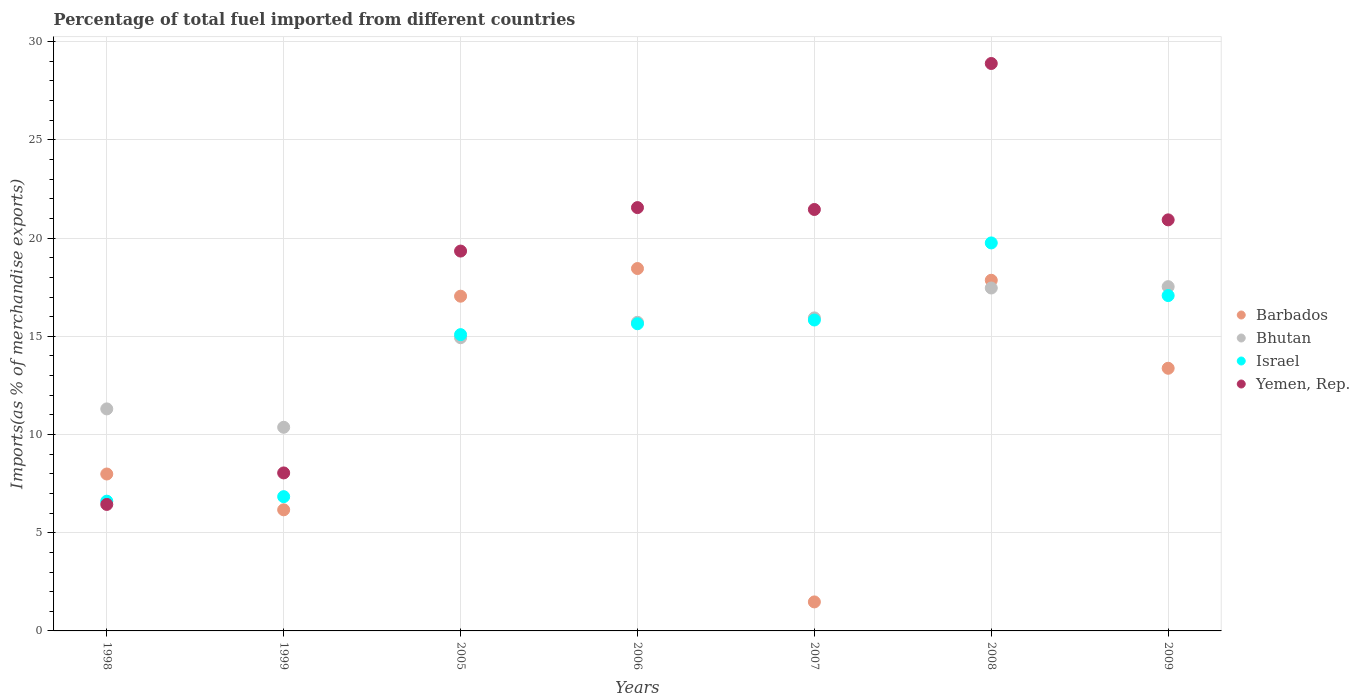How many different coloured dotlines are there?
Keep it short and to the point. 4. What is the percentage of imports to different countries in Barbados in 2009?
Offer a very short reply. 13.37. Across all years, what is the maximum percentage of imports to different countries in Bhutan?
Give a very brief answer. 17.53. Across all years, what is the minimum percentage of imports to different countries in Yemen, Rep.?
Ensure brevity in your answer.  6.44. In which year was the percentage of imports to different countries in Yemen, Rep. maximum?
Your response must be concise. 2008. In which year was the percentage of imports to different countries in Bhutan minimum?
Your response must be concise. 1999. What is the total percentage of imports to different countries in Israel in the graph?
Your answer should be compact. 96.83. What is the difference between the percentage of imports to different countries in Israel in 1999 and that in 2008?
Provide a succinct answer. -12.92. What is the difference between the percentage of imports to different countries in Barbados in 2006 and the percentage of imports to different countries in Yemen, Rep. in 1998?
Offer a terse response. 12.01. What is the average percentage of imports to different countries in Israel per year?
Provide a short and direct response. 13.83. In the year 1998, what is the difference between the percentage of imports to different countries in Barbados and percentage of imports to different countries in Bhutan?
Provide a succinct answer. -3.31. What is the ratio of the percentage of imports to different countries in Israel in 1999 to that in 2006?
Give a very brief answer. 0.44. Is the percentage of imports to different countries in Bhutan in 2005 less than that in 2006?
Your answer should be compact. Yes. What is the difference between the highest and the second highest percentage of imports to different countries in Israel?
Provide a succinct answer. 2.68. What is the difference between the highest and the lowest percentage of imports to different countries in Israel?
Offer a very short reply. 13.15. In how many years, is the percentage of imports to different countries in Yemen, Rep. greater than the average percentage of imports to different countries in Yemen, Rep. taken over all years?
Give a very brief answer. 5. Is it the case that in every year, the sum of the percentage of imports to different countries in Barbados and percentage of imports to different countries in Israel  is greater than the sum of percentage of imports to different countries in Yemen, Rep. and percentage of imports to different countries in Bhutan?
Keep it short and to the point. No. Is it the case that in every year, the sum of the percentage of imports to different countries in Barbados and percentage of imports to different countries in Yemen, Rep.  is greater than the percentage of imports to different countries in Israel?
Give a very brief answer. Yes. Is the percentage of imports to different countries in Barbados strictly less than the percentage of imports to different countries in Yemen, Rep. over the years?
Your response must be concise. No. What is the difference between two consecutive major ticks on the Y-axis?
Give a very brief answer. 5. Does the graph contain any zero values?
Your response must be concise. No. Does the graph contain grids?
Your answer should be very brief. Yes. How many legend labels are there?
Ensure brevity in your answer.  4. How are the legend labels stacked?
Ensure brevity in your answer.  Vertical. What is the title of the graph?
Offer a terse response. Percentage of total fuel imported from different countries. Does "Japan" appear as one of the legend labels in the graph?
Offer a terse response. No. What is the label or title of the X-axis?
Provide a succinct answer. Years. What is the label or title of the Y-axis?
Ensure brevity in your answer.  Imports(as % of merchandise exports). What is the Imports(as % of merchandise exports) in Barbados in 1998?
Keep it short and to the point. 7.99. What is the Imports(as % of merchandise exports) of Bhutan in 1998?
Offer a very short reply. 11.3. What is the Imports(as % of merchandise exports) in Israel in 1998?
Your answer should be very brief. 6.61. What is the Imports(as % of merchandise exports) of Yemen, Rep. in 1998?
Ensure brevity in your answer.  6.44. What is the Imports(as % of merchandise exports) in Barbados in 1999?
Keep it short and to the point. 6.17. What is the Imports(as % of merchandise exports) of Bhutan in 1999?
Make the answer very short. 10.37. What is the Imports(as % of merchandise exports) in Israel in 1999?
Make the answer very short. 6.84. What is the Imports(as % of merchandise exports) of Yemen, Rep. in 1999?
Make the answer very short. 8.04. What is the Imports(as % of merchandise exports) in Barbados in 2005?
Make the answer very short. 17.04. What is the Imports(as % of merchandise exports) of Bhutan in 2005?
Provide a succinct answer. 14.93. What is the Imports(as % of merchandise exports) of Israel in 2005?
Offer a very short reply. 15.09. What is the Imports(as % of merchandise exports) of Yemen, Rep. in 2005?
Make the answer very short. 19.34. What is the Imports(as % of merchandise exports) of Barbados in 2006?
Provide a succinct answer. 18.45. What is the Imports(as % of merchandise exports) of Bhutan in 2006?
Your answer should be compact. 15.71. What is the Imports(as % of merchandise exports) in Israel in 2006?
Your answer should be compact. 15.64. What is the Imports(as % of merchandise exports) of Yemen, Rep. in 2006?
Keep it short and to the point. 21.55. What is the Imports(as % of merchandise exports) in Barbados in 2007?
Ensure brevity in your answer.  1.48. What is the Imports(as % of merchandise exports) of Bhutan in 2007?
Your response must be concise. 15.94. What is the Imports(as % of merchandise exports) of Israel in 2007?
Provide a succinct answer. 15.83. What is the Imports(as % of merchandise exports) in Yemen, Rep. in 2007?
Keep it short and to the point. 21.46. What is the Imports(as % of merchandise exports) in Barbados in 2008?
Offer a terse response. 17.85. What is the Imports(as % of merchandise exports) in Bhutan in 2008?
Your answer should be compact. 17.46. What is the Imports(as % of merchandise exports) of Israel in 2008?
Give a very brief answer. 19.76. What is the Imports(as % of merchandise exports) in Yemen, Rep. in 2008?
Provide a succinct answer. 28.89. What is the Imports(as % of merchandise exports) in Barbados in 2009?
Make the answer very short. 13.37. What is the Imports(as % of merchandise exports) in Bhutan in 2009?
Keep it short and to the point. 17.53. What is the Imports(as % of merchandise exports) of Israel in 2009?
Provide a short and direct response. 17.07. What is the Imports(as % of merchandise exports) of Yemen, Rep. in 2009?
Provide a short and direct response. 20.93. Across all years, what is the maximum Imports(as % of merchandise exports) in Barbados?
Make the answer very short. 18.45. Across all years, what is the maximum Imports(as % of merchandise exports) of Bhutan?
Your answer should be very brief. 17.53. Across all years, what is the maximum Imports(as % of merchandise exports) of Israel?
Offer a terse response. 19.76. Across all years, what is the maximum Imports(as % of merchandise exports) in Yemen, Rep.?
Provide a succinct answer. 28.89. Across all years, what is the minimum Imports(as % of merchandise exports) in Barbados?
Offer a terse response. 1.48. Across all years, what is the minimum Imports(as % of merchandise exports) in Bhutan?
Provide a short and direct response. 10.37. Across all years, what is the minimum Imports(as % of merchandise exports) in Israel?
Your answer should be compact. 6.61. Across all years, what is the minimum Imports(as % of merchandise exports) in Yemen, Rep.?
Your response must be concise. 6.44. What is the total Imports(as % of merchandise exports) in Barbados in the graph?
Ensure brevity in your answer.  82.36. What is the total Imports(as % of merchandise exports) in Bhutan in the graph?
Provide a short and direct response. 103.24. What is the total Imports(as % of merchandise exports) of Israel in the graph?
Offer a terse response. 96.83. What is the total Imports(as % of merchandise exports) in Yemen, Rep. in the graph?
Ensure brevity in your answer.  126.66. What is the difference between the Imports(as % of merchandise exports) of Barbados in 1998 and that in 1999?
Your answer should be very brief. 1.82. What is the difference between the Imports(as % of merchandise exports) of Bhutan in 1998 and that in 1999?
Give a very brief answer. 0.94. What is the difference between the Imports(as % of merchandise exports) of Israel in 1998 and that in 1999?
Give a very brief answer. -0.23. What is the difference between the Imports(as % of merchandise exports) of Yemen, Rep. in 1998 and that in 1999?
Provide a succinct answer. -1.6. What is the difference between the Imports(as % of merchandise exports) of Barbados in 1998 and that in 2005?
Make the answer very short. -9.05. What is the difference between the Imports(as % of merchandise exports) of Bhutan in 1998 and that in 2005?
Your answer should be very brief. -3.62. What is the difference between the Imports(as % of merchandise exports) in Israel in 1998 and that in 2005?
Keep it short and to the point. -8.48. What is the difference between the Imports(as % of merchandise exports) in Yemen, Rep. in 1998 and that in 2005?
Give a very brief answer. -12.9. What is the difference between the Imports(as % of merchandise exports) of Barbados in 1998 and that in 2006?
Provide a short and direct response. -10.46. What is the difference between the Imports(as % of merchandise exports) of Bhutan in 1998 and that in 2006?
Provide a short and direct response. -4.41. What is the difference between the Imports(as % of merchandise exports) in Israel in 1998 and that in 2006?
Offer a terse response. -9.03. What is the difference between the Imports(as % of merchandise exports) in Yemen, Rep. in 1998 and that in 2006?
Keep it short and to the point. -15.11. What is the difference between the Imports(as % of merchandise exports) of Barbados in 1998 and that in 2007?
Your answer should be very brief. 6.51. What is the difference between the Imports(as % of merchandise exports) of Bhutan in 1998 and that in 2007?
Offer a very short reply. -4.63. What is the difference between the Imports(as % of merchandise exports) of Israel in 1998 and that in 2007?
Your answer should be very brief. -9.22. What is the difference between the Imports(as % of merchandise exports) in Yemen, Rep. in 1998 and that in 2007?
Give a very brief answer. -15.02. What is the difference between the Imports(as % of merchandise exports) in Barbados in 1998 and that in 2008?
Your answer should be compact. -9.86. What is the difference between the Imports(as % of merchandise exports) in Bhutan in 1998 and that in 2008?
Make the answer very short. -6.16. What is the difference between the Imports(as % of merchandise exports) of Israel in 1998 and that in 2008?
Keep it short and to the point. -13.15. What is the difference between the Imports(as % of merchandise exports) of Yemen, Rep. in 1998 and that in 2008?
Provide a short and direct response. -22.45. What is the difference between the Imports(as % of merchandise exports) in Barbados in 1998 and that in 2009?
Offer a terse response. -5.38. What is the difference between the Imports(as % of merchandise exports) of Bhutan in 1998 and that in 2009?
Provide a short and direct response. -6.22. What is the difference between the Imports(as % of merchandise exports) of Israel in 1998 and that in 2009?
Keep it short and to the point. -10.47. What is the difference between the Imports(as % of merchandise exports) in Yemen, Rep. in 1998 and that in 2009?
Provide a succinct answer. -14.49. What is the difference between the Imports(as % of merchandise exports) in Barbados in 1999 and that in 2005?
Provide a short and direct response. -10.88. What is the difference between the Imports(as % of merchandise exports) in Bhutan in 1999 and that in 2005?
Offer a terse response. -4.56. What is the difference between the Imports(as % of merchandise exports) in Israel in 1999 and that in 2005?
Make the answer very short. -8.25. What is the difference between the Imports(as % of merchandise exports) of Yemen, Rep. in 1999 and that in 2005?
Keep it short and to the point. -11.3. What is the difference between the Imports(as % of merchandise exports) of Barbados in 1999 and that in 2006?
Make the answer very short. -12.29. What is the difference between the Imports(as % of merchandise exports) in Bhutan in 1999 and that in 2006?
Your answer should be compact. -5.35. What is the difference between the Imports(as % of merchandise exports) of Israel in 1999 and that in 2006?
Your answer should be compact. -8.8. What is the difference between the Imports(as % of merchandise exports) in Yemen, Rep. in 1999 and that in 2006?
Make the answer very short. -13.51. What is the difference between the Imports(as % of merchandise exports) of Barbados in 1999 and that in 2007?
Keep it short and to the point. 4.69. What is the difference between the Imports(as % of merchandise exports) in Bhutan in 1999 and that in 2007?
Offer a terse response. -5.57. What is the difference between the Imports(as % of merchandise exports) of Israel in 1999 and that in 2007?
Provide a short and direct response. -8.99. What is the difference between the Imports(as % of merchandise exports) in Yemen, Rep. in 1999 and that in 2007?
Give a very brief answer. -13.41. What is the difference between the Imports(as % of merchandise exports) of Barbados in 1999 and that in 2008?
Your answer should be compact. -11.69. What is the difference between the Imports(as % of merchandise exports) in Bhutan in 1999 and that in 2008?
Provide a short and direct response. -7.09. What is the difference between the Imports(as % of merchandise exports) of Israel in 1999 and that in 2008?
Offer a very short reply. -12.92. What is the difference between the Imports(as % of merchandise exports) in Yemen, Rep. in 1999 and that in 2008?
Keep it short and to the point. -20.85. What is the difference between the Imports(as % of merchandise exports) in Barbados in 1999 and that in 2009?
Provide a short and direct response. -7.21. What is the difference between the Imports(as % of merchandise exports) of Bhutan in 1999 and that in 2009?
Offer a very short reply. -7.16. What is the difference between the Imports(as % of merchandise exports) of Israel in 1999 and that in 2009?
Ensure brevity in your answer.  -10.24. What is the difference between the Imports(as % of merchandise exports) in Yemen, Rep. in 1999 and that in 2009?
Keep it short and to the point. -12.88. What is the difference between the Imports(as % of merchandise exports) in Barbados in 2005 and that in 2006?
Provide a short and direct response. -1.41. What is the difference between the Imports(as % of merchandise exports) of Bhutan in 2005 and that in 2006?
Your response must be concise. -0.79. What is the difference between the Imports(as % of merchandise exports) in Israel in 2005 and that in 2006?
Keep it short and to the point. -0.55. What is the difference between the Imports(as % of merchandise exports) of Yemen, Rep. in 2005 and that in 2006?
Provide a short and direct response. -2.21. What is the difference between the Imports(as % of merchandise exports) of Barbados in 2005 and that in 2007?
Provide a short and direct response. 15.57. What is the difference between the Imports(as % of merchandise exports) of Bhutan in 2005 and that in 2007?
Ensure brevity in your answer.  -1.01. What is the difference between the Imports(as % of merchandise exports) of Israel in 2005 and that in 2007?
Your answer should be very brief. -0.74. What is the difference between the Imports(as % of merchandise exports) in Yemen, Rep. in 2005 and that in 2007?
Give a very brief answer. -2.12. What is the difference between the Imports(as % of merchandise exports) of Barbados in 2005 and that in 2008?
Give a very brief answer. -0.81. What is the difference between the Imports(as % of merchandise exports) of Bhutan in 2005 and that in 2008?
Offer a terse response. -2.53. What is the difference between the Imports(as % of merchandise exports) in Israel in 2005 and that in 2008?
Offer a very short reply. -4.67. What is the difference between the Imports(as % of merchandise exports) in Yemen, Rep. in 2005 and that in 2008?
Give a very brief answer. -9.55. What is the difference between the Imports(as % of merchandise exports) of Barbados in 2005 and that in 2009?
Ensure brevity in your answer.  3.67. What is the difference between the Imports(as % of merchandise exports) in Bhutan in 2005 and that in 2009?
Make the answer very short. -2.6. What is the difference between the Imports(as % of merchandise exports) of Israel in 2005 and that in 2009?
Provide a succinct answer. -1.99. What is the difference between the Imports(as % of merchandise exports) of Yemen, Rep. in 2005 and that in 2009?
Keep it short and to the point. -1.59. What is the difference between the Imports(as % of merchandise exports) in Barbados in 2006 and that in 2007?
Your response must be concise. 16.97. What is the difference between the Imports(as % of merchandise exports) in Bhutan in 2006 and that in 2007?
Provide a short and direct response. -0.22. What is the difference between the Imports(as % of merchandise exports) in Israel in 2006 and that in 2007?
Provide a succinct answer. -0.19. What is the difference between the Imports(as % of merchandise exports) of Yemen, Rep. in 2006 and that in 2007?
Provide a short and direct response. 0.1. What is the difference between the Imports(as % of merchandise exports) in Barbados in 2006 and that in 2008?
Provide a succinct answer. 0.6. What is the difference between the Imports(as % of merchandise exports) of Bhutan in 2006 and that in 2008?
Your answer should be very brief. -1.75. What is the difference between the Imports(as % of merchandise exports) in Israel in 2006 and that in 2008?
Your answer should be very brief. -4.11. What is the difference between the Imports(as % of merchandise exports) in Yemen, Rep. in 2006 and that in 2008?
Your response must be concise. -7.34. What is the difference between the Imports(as % of merchandise exports) in Barbados in 2006 and that in 2009?
Provide a short and direct response. 5.08. What is the difference between the Imports(as % of merchandise exports) of Bhutan in 2006 and that in 2009?
Give a very brief answer. -1.81. What is the difference between the Imports(as % of merchandise exports) of Israel in 2006 and that in 2009?
Provide a short and direct response. -1.43. What is the difference between the Imports(as % of merchandise exports) in Yemen, Rep. in 2006 and that in 2009?
Keep it short and to the point. 0.62. What is the difference between the Imports(as % of merchandise exports) in Barbados in 2007 and that in 2008?
Your answer should be compact. -16.38. What is the difference between the Imports(as % of merchandise exports) of Bhutan in 2007 and that in 2008?
Make the answer very short. -1.52. What is the difference between the Imports(as % of merchandise exports) of Israel in 2007 and that in 2008?
Offer a very short reply. -3.92. What is the difference between the Imports(as % of merchandise exports) of Yemen, Rep. in 2007 and that in 2008?
Your answer should be very brief. -7.43. What is the difference between the Imports(as % of merchandise exports) in Barbados in 2007 and that in 2009?
Ensure brevity in your answer.  -11.9. What is the difference between the Imports(as % of merchandise exports) in Bhutan in 2007 and that in 2009?
Make the answer very short. -1.59. What is the difference between the Imports(as % of merchandise exports) in Israel in 2007 and that in 2009?
Offer a terse response. -1.24. What is the difference between the Imports(as % of merchandise exports) of Yemen, Rep. in 2007 and that in 2009?
Provide a short and direct response. 0.53. What is the difference between the Imports(as % of merchandise exports) of Barbados in 2008 and that in 2009?
Offer a very short reply. 4.48. What is the difference between the Imports(as % of merchandise exports) in Bhutan in 2008 and that in 2009?
Make the answer very short. -0.07. What is the difference between the Imports(as % of merchandise exports) in Israel in 2008 and that in 2009?
Provide a short and direct response. 2.68. What is the difference between the Imports(as % of merchandise exports) of Yemen, Rep. in 2008 and that in 2009?
Offer a very short reply. 7.96. What is the difference between the Imports(as % of merchandise exports) in Barbados in 1998 and the Imports(as % of merchandise exports) in Bhutan in 1999?
Make the answer very short. -2.38. What is the difference between the Imports(as % of merchandise exports) in Barbados in 1998 and the Imports(as % of merchandise exports) in Israel in 1999?
Keep it short and to the point. 1.15. What is the difference between the Imports(as % of merchandise exports) in Barbados in 1998 and the Imports(as % of merchandise exports) in Yemen, Rep. in 1999?
Provide a short and direct response. -0.05. What is the difference between the Imports(as % of merchandise exports) in Bhutan in 1998 and the Imports(as % of merchandise exports) in Israel in 1999?
Keep it short and to the point. 4.47. What is the difference between the Imports(as % of merchandise exports) of Bhutan in 1998 and the Imports(as % of merchandise exports) of Yemen, Rep. in 1999?
Keep it short and to the point. 3.26. What is the difference between the Imports(as % of merchandise exports) of Israel in 1998 and the Imports(as % of merchandise exports) of Yemen, Rep. in 1999?
Provide a short and direct response. -1.44. What is the difference between the Imports(as % of merchandise exports) in Barbados in 1998 and the Imports(as % of merchandise exports) in Bhutan in 2005?
Provide a succinct answer. -6.94. What is the difference between the Imports(as % of merchandise exports) in Barbados in 1998 and the Imports(as % of merchandise exports) in Israel in 2005?
Ensure brevity in your answer.  -7.1. What is the difference between the Imports(as % of merchandise exports) of Barbados in 1998 and the Imports(as % of merchandise exports) of Yemen, Rep. in 2005?
Ensure brevity in your answer.  -11.35. What is the difference between the Imports(as % of merchandise exports) of Bhutan in 1998 and the Imports(as % of merchandise exports) of Israel in 2005?
Your answer should be compact. -3.78. What is the difference between the Imports(as % of merchandise exports) in Bhutan in 1998 and the Imports(as % of merchandise exports) in Yemen, Rep. in 2005?
Make the answer very short. -8.04. What is the difference between the Imports(as % of merchandise exports) in Israel in 1998 and the Imports(as % of merchandise exports) in Yemen, Rep. in 2005?
Offer a terse response. -12.73. What is the difference between the Imports(as % of merchandise exports) in Barbados in 1998 and the Imports(as % of merchandise exports) in Bhutan in 2006?
Your answer should be compact. -7.72. What is the difference between the Imports(as % of merchandise exports) in Barbados in 1998 and the Imports(as % of merchandise exports) in Israel in 2006?
Your answer should be very brief. -7.65. What is the difference between the Imports(as % of merchandise exports) in Barbados in 1998 and the Imports(as % of merchandise exports) in Yemen, Rep. in 2006?
Ensure brevity in your answer.  -13.56. What is the difference between the Imports(as % of merchandise exports) of Bhutan in 1998 and the Imports(as % of merchandise exports) of Israel in 2006?
Give a very brief answer. -4.34. What is the difference between the Imports(as % of merchandise exports) of Bhutan in 1998 and the Imports(as % of merchandise exports) of Yemen, Rep. in 2006?
Your answer should be very brief. -10.25. What is the difference between the Imports(as % of merchandise exports) in Israel in 1998 and the Imports(as % of merchandise exports) in Yemen, Rep. in 2006?
Give a very brief answer. -14.95. What is the difference between the Imports(as % of merchandise exports) in Barbados in 1998 and the Imports(as % of merchandise exports) in Bhutan in 2007?
Keep it short and to the point. -7.95. What is the difference between the Imports(as % of merchandise exports) of Barbados in 1998 and the Imports(as % of merchandise exports) of Israel in 2007?
Your response must be concise. -7.84. What is the difference between the Imports(as % of merchandise exports) in Barbados in 1998 and the Imports(as % of merchandise exports) in Yemen, Rep. in 2007?
Make the answer very short. -13.47. What is the difference between the Imports(as % of merchandise exports) in Bhutan in 1998 and the Imports(as % of merchandise exports) in Israel in 2007?
Provide a short and direct response. -4.53. What is the difference between the Imports(as % of merchandise exports) of Bhutan in 1998 and the Imports(as % of merchandise exports) of Yemen, Rep. in 2007?
Keep it short and to the point. -10.15. What is the difference between the Imports(as % of merchandise exports) in Israel in 1998 and the Imports(as % of merchandise exports) in Yemen, Rep. in 2007?
Your answer should be compact. -14.85. What is the difference between the Imports(as % of merchandise exports) of Barbados in 1998 and the Imports(as % of merchandise exports) of Bhutan in 2008?
Ensure brevity in your answer.  -9.47. What is the difference between the Imports(as % of merchandise exports) of Barbados in 1998 and the Imports(as % of merchandise exports) of Israel in 2008?
Make the answer very short. -11.77. What is the difference between the Imports(as % of merchandise exports) in Barbados in 1998 and the Imports(as % of merchandise exports) in Yemen, Rep. in 2008?
Give a very brief answer. -20.9. What is the difference between the Imports(as % of merchandise exports) in Bhutan in 1998 and the Imports(as % of merchandise exports) in Israel in 2008?
Provide a succinct answer. -8.45. What is the difference between the Imports(as % of merchandise exports) of Bhutan in 1998 and the Imports(as % of merchandise exports) of Yemen, Rep. in 2008?
Provide a short and direct response. -17.59. What is the difference between the Imports(as % of merchandise exports) of Israel in 1998 and the Imports(as % of merchandise exports) of Yemen, Rep. in 2008?
Your response must be concise. -22.28. What is the difference between the Imports(as % of merchandise exports) in Barbados in 1998 and the Imports(as % of merchandise exports) in Bhutan in 2009?
Your response must be concise. -9.54. What is the difference between the Imports(as % of merchandise exports) of Barbados in 1998 and the Imports(as % of merchandise exports) of Israel in 2009?
Provide a short and direct response. -9.08. What is the difference between the Imports(as % of merchandise exports) in Barbados in 1998 and the Imports(as % of merchandise exports) in Yemen, Rep. in 2009?
Provide a short and direct response. -12.94. What is the difference between the Imports(as % of merchandise exports) in Bhutan in 1998 and the Imports(as % of merchandise exports) in Israel in 2009?
Keep it short and to the point. -5.77. What is the difference between the Imports(as % of merchandise exports) of Bhutan in 1998 and the Imports(as % of merchandise exports) of Yemen, Rep. in 2009?
Make the answer very short. -9.62. What is the difference between the Imports(as % of merchandise exports) in Israel in 1998 and the Imports(as % of merchandise exports) in Yemen, Rep. in 2009?
Your answer should be very brief. -14.32. What is the difference between the Imports(as % of merchandise exports) in Barbados in 1999 and the Imports(as % of merchandise exports) in Bhutan in 2005?
Provide a succinct answer. -8.76. What is the difference between the Imports(as % of merchandise exports) of Barbados in 1999 and the Imports(as % of merchandise exports) of Israel in 2005?
Make the answer very short. -8.92. What is the difference between the Imports(as % of merchandise exports) in Barbados in 1999 and the Imports(as % of merchandise exports) in Yemen, Rep. in 2005?
Offer a very short reply. -13.17. What is the difference between the Imports(as % of merchandise exports) of Bhutan in 1999 and the Imports(as % of merchandise exports) of Israel in 2005?
Offer a terse response. -4.72. What is the difference between the Imports(as % of merchandise exports) of Bhutan in 1999 and the Imports(as % of merchandise exports) of Yemen, Rep. in 2005?
Ensure brevity in your answer.  -8.97. What is the difference between the Imports(as % of merchandise exports) of Israel in 1999 and the Imports(as % of merchandise exports) of Yemen, Rep. in 2005?
Your answer should be very brief. -12.5. What is the difference between the Imports(as % of merchandise exports) of Barbados in 1999 and the Imports(as % of merchandise exports) of Bhutan in 2006?
Give a very brief answer. -9.55. What is the difference between the Imports(as % of merchandise exports) in Barbados in 1999 and the Imports(as % of merchandise exports) in Israel in 2006?
Keep it short and to the point. -9.47. What is the difference between the Imports(as % of merchandise exports) in Barbados in 1999 and the Imports(as % of merchandise exports) in Yemen, Rep. in 2006?
Make the answer very short. -15.39. What is the difference between the Imports(as % of merchandise exports) of Bhutan in 1999 and the Imports(as % of merchandise exports) of Israel in 2006?
Your answer should be compact. -5.27. What is the difference between the Imports(as % of merchandise exports) of Bhutan in 1999 and the Imports(as % of merchandise exports) of Yemen, Rep. in 2006?
Provide a succinct answer. -11.19. What is the difference between the Imports(as % of merchandise exports) of Israel in 1999 and the Imports(as % of merchandise exports) of Yemen, Rep. in 2006?
Give a very brief answer. -14.72. What is the difference between the Imports(as % of merchandise exports) of Barbados in 1999 and the Imports(as % of merchandise exports) of Bhutan in 2007?
Ensure brevity in your answer.  -9.77. What is the difference between the Imports(as % of merchandise exports) of Barbados in 1999 and the Imports(as % of merchandise exports) of Israel in 2007?
Ensure brevity in your answer.  -9.66. What is the difference between the Imports(as % of merchandise exports) in Barbados in 1999 and the Imports(as % of merchandise exports) in Yemen, Rep. in 2007?
Your answer should be compact. -15.29. What is the difference between the Imports(as % of merchandise exports) of Bhutan in 1999 and the Imports(as % of merchandise exports) of Israel in 2007?
Ensure brevity in your answer.  -5.46. What is the difference between the Imports(as % of merchandise exports) of Bhutan in 1999 and the Imports(as % of merchandise exports) of Yemen, Rep. in 2007?
Provide a succinct answer. -11.09. What is the difference between the Imports(as % of merchandise exports) of Israel in 1999 and the Imports(as % of merchandise exports) of Yemen, Rep. in 2007?
Give a very brief answer. -14.62. What is the difference between the Imports(as % of merchandise exports) in Barbados in 1999 and the Imports(as % of merchandise exports) in Bhutan in 2008?
Offer a very short reply. -11.29. What is the difference between the Imports(as % of merchandise exports) of Barbados in 1999 and the Imports(as % of merchandise exports) of Israel in 2008?
Ensure brevity in your answer.  -13.59. What is the difference between the Imports(as % of merchandise exports) in Barbados in 1999 and the Imports(as % of merchandise exports) in Yemen, Rep. in 2008?
Provide a succinct answer. -22.72. What is the difference between the Imports(as % of merchandise exports) of Bhutan in 1999 and the Imports(as % of merchandise exports) of Israel in 2008?
Ensure brevity in your answer.  -9.39. What is the difference between the Imports(as % of merchandise exports) in Bhutan in 1999 and the Imports(as % of merchandise exports) in Yemen, Rep. in 2008?
Your response must be concise. -18.52. What is the difference between the Imports(as % of merchandise exports) in Israel in 1999 and the Imports(as % of merchandise exports) in Yemen, Rep. in 2008?
Your response must be concise. -22.06. What is the difference between the Imports(as % of merchandise exports) in Barbados in 1999 and the Imports(as % of merchandise exports) in Bhutan in 2009?
Ensure brevity in your answer.  -11.36. What is the difference between the Imports(as % of merchandise exports) of Barbados in 1999 and the Imports(as % of merchandise exports) of Israel in 2009?
Your response must be concise. -10.91. What is the difference between the Imports(as % of merchandise exports) in Barbados in 1999 and the Imports(as % of merchandise exports) in Yemen, Rep. in 2009?
Offer a terse response. -14.76. What is the difference between the Imports(as % of merchandise exports) of Bhutan in 1999 and the Imports(as % of merchandise exports) of Israel in 2009?
Give a very brief answer. -6.71. What is the difference between the Imports(as % of merchandise exports) of Bhutan in 1999 and the Imports(as % of merchandise exports) of Yemen, Rep. in 2009?
Provide a short and direct response. -10.56. What is the difference between the Imports(as % of merchandise exports) of Israel in 1999 and the Imports(as % of merchandise exports) of Yemen, Rep. in 2009?
Make the answer very short. -14.09. What is the difference between the Imports(as % of merchandise exports) of Barbados in 2005 and the Imports(as % of merchandise exports) of Bhutan in 2006?
Keep it short and to the point. 1.33. What is the difference between the Imports(as % of merchandise exports) of Barbados in 2005 and the Imports(as % of merchandise exports) of Israel in 2006?
Offer a terse response. 1.4. What is the difference between the Imports(as % of merchandise exports) of Barbados in 2005 and the Imports(as % of merchandise exports) of Yemen, Rep. in 2006?
Make the answer very short. -4.51. What is the difference between the Imports(as % of merchandise exports) in Bhutan in 2005 and the Imports(as % of merchandise exports) in Israel in 2006?
Your response must be concise. -0.71. What is the difference between the Imports(as % of merchandise exports) of Bhutan in 2005 and the Imports(as % of merchandise exports) of Yemen, Rep. in 2006?
Provide a short and direct response. -6.62. What is the difference between the Imports(as % of merchandise exports) of Israel in 2005 and the Imports(as % of merchandise exports) of Yemen, Rep. in 2006?
Your answer should be compact. -6.47. What is the difference between the Imports(as % of merchandise exports) in Barbados in 2005 and the Imports(as % of merchandise exports) in Bhutan in 2007?
Offer a very short reply. 1.11. What is the difference between the Imports(as % of merchandise exports) of Barbados in 2005 and the Imports(as % of merchandise exports) of Israel in 2007?
Offer a very short reply. 1.21. What is the difference between the Imports(as % of merchandise exports) in Barbados in 2005 and the Imports(as % of merchandise exports) in Yemen, Rep. in 2007?
Provide a short and direct response. -4.42. What is the difference between the Imports(as % of merchandise exports) of Bhutan in 2005 and the Imports(as % of merchandise exports) of Israel in 2007?
Offer a terse response. -0.9. What is the difference between the Imports(as % of merchandise exports) in Bhutan in 2005 and the Imports(as % of merchandise exports) in Yemen, Rep. in 2007?
Provide a short and direct response. -6.53. What is the difference between the Imports(as % of merchandise exports) in Israel in 2005 and the Imports(as % of merchandise exports) in Yemen, Rep. in 2007?
Offer a very short reply. -6.37. What is the difference between the Imports(as % of merchandise exports) of Barbados in 2005 and the Imports(as % of merchandise exports) of Bhutan in 2008?
Ensure brevity in your answer.  -0.42. What is the difference between the Imports(as % of merchandise exports) of Barbados in 2005 and the Imports(as % of merchandise exports) of Israel in 2008?
Ensure brevity in your answer.  -2.71. What is the difference between the Imports(as % of merchandise exports) of Barbados in 2005 and the Imports(as % of merchandise exports) of Yemen, Rep. in 2008?
Offer a terse response. -11.85. What is the difference between the Imports(as % of merchandise exports) in Bhutan in 2005 and the Imports(as % of merchandise exports) in Israel in 2008?
Give a very brief answer. -4.83. What is the difference between the Imports(as % of merchandise exports) in Bhutan in 2005 and the Imports(as % of merchandise exports) in Yemen, Rep. in 2008?
Your response must be concise. -13.96. What is the difference between the Imports(as % of merchandise exports) in Israel in 2005 and the Imports(as % of merchandise exports) in Yemen, Rep. in 2008?
Your response must be concise. -13.81. What is the difference between the Imports(as % of merchandise exports) in Barbados in 2005 and the Imports(as % of merchandise exports) in Bhutan in 2009?
Keep it short and to the point. -0.49. What is the difference between the Imports(as % of merchandise exports) in Barbados in 2005 and the Imports(as % of merchandise exports) in Israel in 2009?
Give a very brief answer. -0.03. What is the difference between the Imports(as % of merchandise exports) of Barbados in 2005 and the Imports(as % of merchandise exports) of Yemen, Rep. in 2009?
Give a very brief answer. -3.89. What is the difference between the Imports(as % of merchandise exports) of Bhutan in 2005 and the Imports(as % of merchandise exports) of Israel in 2009?
Make the answer very short. -2.15. What is the difference between the Imports(as % of merchandise exports) of Bhutan in 2005 and the Imports(as % of merchandise exports) of Yemen, Rep. in 2009?
Provide a short and direct response. -6. What is the difference between the Imports(as % of merchandise exports) in Israel in 2005 and the Imports(as % of merchandise exports) in Yemen, Rep. in 2009?
Make the answer very short. -5.84. What is the difference between the Imports(as % of merchandise exports) in Barbados in 2006 and the Imports(as % of merchandise exports) in Bhutan in 2007?
Offer a very short reply. 2.51. What is the difference between the Imports(as % of merchandise exports) in Barbados in 2006 and the Imports(as % of merchandise exports) in Israel in 2007?
Give a very brief answer. 2.62. What is the difference between the Imports(as % of merchandise exports) in Barbados in 2006 and the Imports(as % of merchandise exports) in Yemen, Rep. in 2007?
Offer a very short reply. -3.01. What is the difference between the Imports(as % of merchandise exports) in Bhutan in 2006 and the Imports(as % of merchandise exports) in Israel in 2007?
Offer a terse response. -0.12. What is the difference between the Imports(as % of merchandise exports) of Bhutan in 2006 and the Imports(as % of merchandise exports) of Yemen, Rep. in 2007?
Make the answer very short. -5.74. What is the difference between the Imports(as % of merchandise exports) in Israel in 2006 and the Imports(as % of merchandise exports) in Yemen, Rep. in 2007?
Your response must be concise. -5.82. What is the difference between the Imports(as % of merchandise exports) in Barbados in 2006 and the Imports(as % of merchandise exports) in Israel in 2008?
Ensure brevity in your answer.  -1.3. What is the difference between the Imports(as % of merchandise exports) in Barbados in 2006 and the Imports(as % of merchandise exports) in Yemen, Rep. in 2008?
Provide a succinct answer. -10.44. What is the difference between the Imports(as % of merchandise exports) in Bhutan in 2006 and the Imports(as % of merchandise exports) in Israel in 2008?
Offer a very short reply. -4.04. What is the difference between the Imports(as % of merchandise exports) of Bhutan in 2006 and the Imports(as % of merchandise exports) of Yemen, Rep. in 2008?
Give a very brief answer. -13.18. What is the difference between the Imports(as % of merchandise exports) in Israel in 2006 and the Imports(as % of merchandise exports) in Yemen, Rep. in 2008?
Offer a terse response. -13.25. What is the difference between the Imports(as % of merchandise exports) of Barbados in 2006 and the Imports(as % of merchandise exports) of Bhutan in 2009?
Your answer should be compact. 0.92. What is the difference between the Imports(as % of merchandise exports) of Barbados in 2006 and the Imports(as % of merchandise exports) of Israel in 2009?
Provide a succinct answer. 1.38. What is the difference between the Imports(as % of merchandise exports) in Barbados in 2006 and the Imports(as % of merchandise exports) in Yemen, Rep. in 2009?
Offer a very short reply. -2.48. What is the difference between the Imports(as % of merchandise exports) in Bhutan in 2006 and the Imports(as % of merchandise exports) in Israel in 2009?
Provide a succinct answer. -1.36. What is the difference between the Imports(as % of merchandise exports) in Bhutan in 2006 and the Imports(as % of merchandise exports) in Yemen, Rep. in 2009?
Offer a very short reply. -5.21. What is the difference between the Imports(as % of merchandise exports) in Israel in 2006 and the Imports(as % of merchandise exports) in Yemen, Rep. in 2009?
Offer a terse response. -5.29. What is the difference between the Imports(as % of merchandise exports) in Barbados in 2007 and the Imports(as % of merchandise exports) in Bhutan in 2008?
Provide a succinct answer. -15.98. What is the difference between the Imports(as % of merchandise exports) in Barbados in 2007 and the Imports(as % of merchandise exports) in Israel in 2008?
Provide a succinct answer. -18.28. What is the difference between the Imports(as % of merchandise exports) in Barbados in 2007 and the Imports(as % of merchandise exports) in Yemen, Rep. in 2008?
Provide a short and direct response. -27.41. What is the difference between the Imports(as % of merchandise exports) of Bhutan in 2007 and the Imports(as % of merchandise exports) of Israel in 2008?
Your answer should be compact. -3.82. What is the difference between the Imports(as % of merchandise exports) of Bhutan in 2007 and the Imports(as % of merchandise exports) of Yemen, Rep. in 2008?
Your response must be concise. -12.95. What is the difference between the Imports(as % of merchandise exports) of Israel in 2007 and the Imports(as % of merchandise exports) of Yemen, Rep. in 2008?
Provide a short and direct response. -13.06. What is the difference between the Imports(as % of merchandise exports) in Barbados in 2007 and the Imports(as % of merchandise exports) in Bhutan in 2009?
Make the answer very short. -16.05. What is the difference between the Imports(as % of merchandise exports) of Barbados in 2007 and the Imports(as % of merchandise exports) of Israel in 2009?
Provide a short and direct response. -15.6. What is the difference between the Imports(as % of merchandise exports) in Barbados in 2007 and the Imports(as % of merchandise exports) in Yemen, Rep. in 2009?
Provide a short and direct response. -19.45. What is the difference between the Imports(as % of merchandise exports) in Bhutan in 2007 and the Imports(as % of merchandise exports) in Israel in 2009?
Offer a terse response. -1.14. What is the difference between the Imports(as % of merchandise exports) of Bhutan in 2007 and the Imports(as % of merchandise exports) of Yemen, Rep. in 2009?
Your response must be concise. -4.99. What is the difference between the Imports(as % of merchandise exports) of Israel in 2007 and the Imports(as % of merchandise exports) of Yemen, Rep. in 2009?
Provide a succinct answer. -5.1. What is the difference between the Imports(as % of merchandise exports) of Barbados in 2008 and the Imports(as % of merchandise exports) of Bhutan in 2009?
Keep it short and to the point. 0.32. What is the difference between the Imports(as % of merchandise exports) in Barbados in 2008 and the Imports(as % of merchandise exports) in Israel in 2009?
Provide a succinct answer. 0.78. What is the difference between the Imports(as % of merchandise exports) of Barbados in 2008 and the Imports(as % of merchandise exports) of Yemen, Rep. in 2009?
Your answer should be compact. -3.08. What is the difference between the Imports(as % of merchandise exports) in Bhutan in 2008 and the Imports(as % of merchandise exports) in Israel in 2009?
Provide a succinct answer. 0.39. What is the difference between the Imports(as % of merchandise exports) of Bhutan in 2008 and the Imports(as % of merchandise exports) of Yemen, Rep. in 2009?
Provide a short and direct response. -3.47. What is the difference between the Imports(as % of merchandise exports) in Israel in 2008 and the Imports(as % of merchandise exports) in Yemen, Rep. in 2009?
Your response must be concise. -1.17. What is the average Imports(as % of merchandise exports) of Barbados per year?
Ensure brevity in your answer.  11.77. What is the average Imports(as % of merchandise exports) in Bhutan per year?
Your response must be concise. 14.75. What is the average Imports(as % of merchandise exports) in Israel per year?
Your answer should be very brief. 13.83. What is the average Imports(as % of merchandise exports) in Yemen, Rep. per year?
Provide a succinct answer. 18.09. In the year 1998, what is the difference between the Imports(as % of merchandise exports) in Barbados and Imports(as % of merchandise exports) in Bhutan?
Your answer should be very brief. -3.31. In the year 1998, what is the difference between the Imports(as % of merchandise exports) of Barbados and Imports(as % of merchandise exports) of Israel?
Your answer should be very brief. 1.38. In the year 1998, what is the difference between the Imports(as % of merchandise exports) of Barbados and Imports(as % of merchandise exports) of Yemen, Rep.?
Offer a very short reply. 1.55. In the year 1998, what is the difference between the Imports(as % of merchandise exports) in Bhutan and Imports(as % of merchandise exports) in Israel?
Keep it short and to the point. 4.7. In the year 1998, what is the difference between the Imports(as % of merchandise exports) of Bhutan and Imports(as % of merchandise exports) of Yemen, Rep.?
Keep it short and to the point. 4.86. In the year 1998, what is the difference between the Imports(as % of merchandise exports) in Israel and Imports(as % of merchandise exports) in Yemen, Rep.?
Your answer should be very brief. 0.17. In the year 1999, what is the difference between the Imports(as % of merchandise exports) of Barbados and Imports(as % of merchandise exports) of Bhutan?
Ensure brevity in your answer.  -4.2. In the year 1999, what is the difference between the Imports(as % of merchandise exports) of Barbados and Imports(as % of merchandise exports) of Israel?
Keep it short and to the point. -0.67. In the year 1999, what is the difference between the Imports(as % of merchandise exports) in Barbados and Imports(as % of merchandise exports) in Yemen, Rep.?
Provide a short and direct response. -1.88. In the year 1999, what is the difference between the Imports(as % of merchandise exports) in Bhutan and Imports(as % of merchandise exports) in Israel?
Give a very brief answer. 3.53. In the year 1999, what is the difference between the Imports(as % of merchandise exports) of Bhutan and Imports(as % of merchandise exports) of Yemen, Rep.?
Keep it short and to the point. 2.32. In the year 1999, what is the difference between the Imports(as % of merchandise exports) of Israel and Imports(as % of merchandise exports) of Yemen, Rep.?
Keep it short and to the point. -1.21. In the year 2005, what is the difference between the Imports(as % of merchandise exports) of Barbados and Imports(as % of merchandise exports) of Bhutan?
Ensure brevity in your answer.  2.11. In the year 2005, what is the difference between the Imports(as % of merchandise exports) in Barbados and Imports(as % of merchandise exports) in Israel?
Ensure brevity in your answer.  1.96. In the year 2005, what is the difference between the Imports(as % of merchandise exports) in Barbados and Imports(as % of merchandise exports) in Yemen, Rep.?
Your answer should be compact. -2.3. In the year 2005, what is the difference between the Imports(as % of merchandise exports) of Bhutan and Imports(as % of merchandise exports) of Israel?
Your answer should be compact. -0.16. In the year 2005, what is the difference between the Imports(as % of merchandise exports) of Bhutan and Imports(as % of merchandise exports) of Yemen, Rep.?
Your response must be concise. -4.41. In the year 2005, what is the difference between the Imports(as % of merchandise exports) in Israel and Imports(as % of merchandise exports) in Yemen, Rep.?
Your answer should be very brief. -4.25. In the year 2006, what is the difference between the Imports(as % of merchandise exports) of Barbados and Imports(as % of merchandise exports) of Bhutan?
Offer a very short reply. 2.74. In the year 2006, what is the difference between the Imports(as % of merchandise exports) in Barbados and Imports(as % of merchandise exports) in Israel?
Provide a succinct answer. 2.81. In the year 2006, what is the difference between the Imports(as % of merchandise exports) in Barbados and Imports(as % of merchandise exports) in Yemen, Rep.?
Offer a terse response. -3.1. In the year 2006, what is the difference between the Imports(as % of merchandise exports) in Bhutan and Imports(as % of merchandise exports) in Israel?
Keep it short and to the point. 0.07. In the year 2006, what is the difference between the Imports(as % of merchandise exports) in Bhutan and Imports(as % of merchandise exports) in Yemen, Rep.?
Offer a very short reply. -5.84. In the year 2006, what is the difference between the Imports(as % of merchandise exports) in Israel and Imports(as % of merchandise exports) in Yemen, Rep.?
Keep it short and to the point. -5.91. In the year 2007, what is the difference between the Imports(as % of merchandise exports) in Barbados and Imports(as % of merchandise exports) in Bhutan?
Your answer should be very brief. -14.46. In the year 2007, what is the difference between the Imports(as % of merchandise exports) in Barbados and Imports(as % of merchandise exports) in Israel?
Offer a terse response. -14.35. In the year 2007, what is the difference between the Imports(as % of merchandise exports) of Barbados and Imports(as % of merchandise exports) of Yemen, Rep.?
Keep it short and to the point. -19.98. In the year 2007, what is the difference between the Imports(as % of merchandise exports) of Bhutan and Imports(as % of merchandise exports) of Israel?
Provide a short and direct response. 0.11. In the year 2007, what is the difference between the Imports(as % of merchandise exports) of Bhutan and Imports(as % of merchandise exports) of Yemen, Rep.?
Your response must be concise. -5.52. In the year 2007, what is the difference between the Imports(as % of merchandise exports) in Israel and Imports(as % of merchandise exports) in Yemen, Rep.?
Provide a succinct answer. -5.63. In the year 2008, what is the difference between the Imports(as % of merchandise exports) in Barbados and Imports(as % of merchandise exports) in Bhutan?
Provide a short and direct response. 0.39. In the year 2008, what is the difference between the Imports(as % of merchandise exports) of Barbados and Imports(as % of merchandise exports) of Israel?
Ensure brevity in your answer.  -1.9. In the year 2008, what is the difference between the Imports(as % of merchandise exports) of Barbados and Imports(as % of merchandise exports) of Yemen, Rep.?
Provide a succinct answer. -11.04. In the year 2008, what is the difference between the Imports(as % of merchandise exports) of Bhutan and Imports(as % of merchandise exports) of Israel?
Give a very brief answer. -2.29. In the year 2008, what is the difference between the Imports(as % of merchandise exports) in Bhutan and Imports(as % of merchandise exports) in Yemen, Rep.?
Ensure brevity in your answer.  -11.43. In the year 2008, what is the difference between the Imports(as % of merchandise exports) in Israel and Imports(as % of merchandise exports) in Yemen, Rep.?
Provide a short and direct response. -9.14. In the year 2009, what is the difference between the Imports(as % of merchandise exports) in Barbados and Imports(as % of merchandise exports) in Bhutan?
Offer a terse response. -4.16. In the year 2009, what is the difference between the Imports(as % of merchandise exports) in Barbados and Imports(as % of merchandise exports) in Israel?
Provide a succinct answer. -3.7. In the year 2009, what is the difference between the Imports(as % of merchandise exports) of Barbados and Imports(as % of merchandise exports) of Yemen, Rep.?
Your answer should be very brief. -7.56. In the year 2009, what is the difference between the Imports(as % of merchandise exports) of Bhutan and Imports(as % of merchandise exports) of Israel?
Offer a very short reply. 0.45. In the year 2009, what is the difference between the Imports(as % of merchandise exports) of Bhutan and Imports(as % of merchandise exports) of Yemen, Rep.?
Provide a short and direct response. -3.4. In the year 2009, what is the difference between the Imports(as % of merchandise exports) in Israel and Imports(as % of merchandise exports) in Yemen, Rep.?
Give a very brief answer. -3.85. What is the ratio of the Imports(as % of merchandise exports) of Barbados in 1998 to that in 1999?
Ensure brevity in your answer.  1.3. What is the ratio of the Imports(as % of merchandise exports) in Bhutan in 1998 to that in 1999?
Your answer should be very brief. 1.09. What is the ratio of the Imports(as % of merchandise exports) in Israel in 1998 to that in 1999?
Ensure brevity in your answer.  0.97. What is the ratio of the Imports(as % of merchandise exports) of Yemen, Rep. in 1998 to that in 1999?
Your answer should be compact. 0.8. What is the ratio of the Imports(as % of merchandise exports) of Barbados in 1998 to that in 2005?
Your answer should be very brief. 0.47. What is the ratio of the Imports(as % of merchandise exports) in Bhutan in 1998 to that in 2005?
Ensure brevity in your answer.  0.76. What is the ratio of the Imports(as % of merchandise exports) of Israel in 1998 to that in 2005?
Keep it short and to the point. 0.44. What is the ratio of the Imports(as % of merchandise exports) of Yemen, Rep. in 1998 to that in 2005?
Your answer should be very brief. 0.33. What is the ratio of the Imports(as % of merchandise exports) in Barbados in 1998 to that in 2006?
Offer a very short reply. 0.43. What is the ratio of the Imports(as % of merchandise exports) in Bhutan in 1998 to that in 2006?
Your answer should be very brief. 0.72. What is the ratio of the Imports(as % of merchandise exports) in Israel in 1998 to that in 2006?
Provide a short and direct response. 0.42. What is the ratio of the Imports(as % of merchandise exports) of Yemen, Rep. in 1998 to that in 2006?
Your answer should be compact. 0.3. What is the ratio of the Imports(as % of merchandise exports) in Barbados in 1998 to that in 2007?
Give a very brief answer. 5.41. What is the ratio of the Imports(as % of merchandise exports) in Bhutan in 1998 to that in 2007?
Give a very brief answer. 0.71. What is the ratio of the Imports(as % of merchandise exports) in Israel in 1998 to that in 2007?
Offer a terse response. 0.42. What is the ratio of the Imports(as % of merchandise exports) in Yemen, Rep. in 1998 to that in 2007?
Provide a short and direct response. 0.3. What is the ratio of the Imports(as % of merchandise exports) in Barbados in 1998 to that in 2008?
Your response must be concise. 0.45. What is the ratio of the Imports(as % of merchandise exports) of Bhutan in 1998 to that in 2008?
Ensure brevity in your answer.  0.65. What is the ratio of the Imports(as % of merchandise exports) in Israel in 1998 to that in 2008?
Provide a short and direct response. 0.33. What is the ratio of the Imports(as % of merchandise exports) in Yemen, Rep. in 1998 to that in 2008?
Make the answer very short. 0.22. What is the ratio of the Imports(as % of merchandise exports) in Barbados in 1998 to that in 2009?
Make the answer very short. 0.6. What is the ratio of the Imports(as % of merchandise exports) in Bhutan in 1998 to that in 2009?
Your response must be concise. 0.64. What is the ratio of the Imports(as % of merchandise exports) in Israel in 1998 to that in 2009?
Your answer should be very brief. 0.39. What is the ratio of the Imports(as % of merchandise exports) of Yemen, Rep. in 1998 to that in 2009?
Provide a short and direct response. 0.31. What is the ratio of the Imports(as % of merchandise exports) of Barbados in 1999 to that in 2005?
Offer a very short reply. 0.36. What is the ratio of the Imports(as % of merchandise exports) in Bhutan in 1999 to that in 2005?
Make the answer very short. 0.69. What is the ratio of the Imports(as % of merchandise exports) of Israel in 1999 to that in 2005?
Provide a short and direct response. 0.45. What is the ratio of the Imports(as % of merchandise exports) in Yemen, Rep. in 1999 to that in 2005?
Offer a very short reply. 0.42. What is the ratio of the Imports(as % of merchandise exports) in Barbados in 1999 to that in 2006?
Offer a very short reply. 0.33. What is the ratio of the Imports(as % of merchandise exports) in Bhutan in 1999 to that in 2006?
Give a very brief answer. 0.66. What is the ratio of the Imports(as % of merchandise exports) in Israel in 1999 to that in 2006?
Offer a terse response. 0.44. What is the ratio of the Imports(as % of merchandise exports) of Yemen, Rep. in 1999 to that in 2006?
Your answer should be very brief. 0.37. What is the ratio of the Imports(as % of merchandise exports) of Barbados in 1999 to that in 2007?
Provide a succinct answer. 4.18. What is the ratio of the Imports(as % of merchandise exports) of Bhutan in 1999 to that in 2007?
Your answer should be very brief. 0.65. What is the ratio of the Imports(as % of merchandise exports) in Israel in 1999 to that in 2007?
Provide a succinct answer. 0.43. What is the ratio of the Imports(as % of merchandise exports) in Yemen, Rep. in 1999 to that in 2007?
Ensure brevity in your answer.  0.37. What is the ratio of the Imports(as % of merchandise exports) of Barbados in 1999 to that in 2008?
Give a very brief answer. 0.35. What is the ratio of the Imports(as % of merchandise exports) in Bhutan in 1999 to that in 2008?
Offer a terse response. 0.59. What is the ratio of the Imports(as % of merchandise exports) of Israel in 1999 to that in 2008?
Your answer should be compact. 0.35. What is the ratio of the Imports(as % of merchandise exports) in Yemen, Rep. in 1999 to that in 2008?
Offer a very short reply. 0.28. What is the ratio of the Imports(as % of merchandise exports) in Barbados in 1999 to that in 2009?
Keep it short and to the point. 0.46. What is the ratio of the Imports(as % of merchandise exports) in Bhutan in 1999 to that in 2009?
Keep it short and to the point. 0.59. What is the ratio of the Imports(as % of merchandise exports) in Israel in 1999 to that in 2009?
Give a very brief answer. 0.4. What is the ratio of the Imports(as % of merchandise exports) in Yemen, Rep. in 1999 to that in 2009?
Make the answer very short. 0.38. What is the ratio of the Imports(as % of merchandise exports) in Barbados in 2005 to that in 2006?
Offer a terse response. 0.92. What is the ratio of the Imports(as % of merchandise exports) in Israel in 2005 to that in 2006?
Ensure brevity in your answer.  0.96. What is the ratio of the Imports(as % of merchandise exports) in Yemen, Rep. in 2005 to that in 2006?
Your response must be concise. 0.9. What is the ratio of the Imports(as % of merchandise exports) of Barbados in 2005 to that in 2007?
Provide a succinct answer. 11.54. What is the ratio of the Imports(as % of merchandise exports) of Bhutan in 2005 to that in 2007?
Provide a short and direct response. 0.94. What is the ratio of the Imports(as % of merchandise exports) of Israel in 2005 to that in 2007?
Keep it short and to the point. 0.95. What is the ratio of the Imports(as % of merchandise exports) of Yemen, Rep. in 2005 to that in 2007?
Provide a short and direct response. 0.9. What is the ratio of the Imports(as % of merchandise exports) of Barbados in 2005 to that in 2008?
Provide a short and direct response. 0.95. What is the ratio of the Imports(as % of merchandise exports) of Bhutan in 2005 to that in 2008?
Offer a very short reply. 0.86. What is the ratio of the Imports(as % of merchandise exports) of Israel in 2005 to that in 2008?
Your response must be concise. 0.76. What is the ratio of the Imports(as % of merchandise exports) of Yemen, Rep. in 2005 to that in 2008?
Your response must be concise. 0.67. What is the ratio of the Imports(as % of merchandise exports) in Barbados in 2005 to that in 2009?
Provide a short and direct response. 1.27. What is the ratio of the Imports(as % of merchandise exports) of Bhutan in 2005 to that in 2009?
Your response must be concise. 0.85. What is the ratio of the Imports(as % of merchandise exports) in Israel in 2005 to that in 2009?
Your answer should be very brief. 0.88. What is the ratio of the Imports(as % of merchandise exports) of Yemen, Rep. in 2005 to that in 2009?
Your answer should be compact. 0.92. What is the ratio of the Imports(as % of merchandise exports) in Barbados in 2006 to that in 2007?
Ensure brevity in your answer.  12.49. What is the ratio of the Imports(as % of merchandise exports) in Barbados in 2006 to that in 2008?
Provide a succinct answer. 1.03. What is the ratio of the Imports(as % of merchandise exports) of Israel in 2006 to that in 2008?
Your answer should be compact. 0.79. What is the ratio of the Imports(as % of merchandise exports) in Yemen, Rep. in 2006 to that in 2008?
Make the answer very short. 0.75. What is the ratio of the Imports(as % of merchandise exports) of Barbados in 2006 to that in 2009?
Offer a very short reply. 1.38. What is the ratio of the Imports(as % of merchandise exports) of Bhutan in 2006 to that in 2009?
Your answer should be very brief. 0.9. What is the ratio of the Imports(as % of merchandise exports) in Israel in 2006 to that in 2009?
Ensure brevity in your answer.  0.92. What is the ratio of the Imports(as % of merchandise exports) in Yemen, Rep. in 2006 to that in 2009?
Offer a terse response. 1.03. What is the ratio of the Imports(as % of merchandise exports) in Barbados in 2007 to that in 2008?
Make the answer very short. 0.08. What is the ratio of the Imports(as % of merchandise exports) of Bhutan in 2007 to that in 2008?
Provide a short and direct response. 0.91. What is the ratio of the Imports(as % of merchandise exports) in Israel in 2007 to that in 2008?
Your answer should be very brief. 0.8. What is the ratio of the Imports(as % of merchandise exports) in Yemen, Rep. in 2007 to that in 2008?
Provide a succinct answer. 0.74. What is the ratio of the Imports(as % of merchandise exports) of Barbados in 2007 to that in 2009?
Keep it short and to the point. 0.11. What is the ratio of the Imports(as % of merchandise exports) in Bhutan in 2007 to that in 2009?
Make the answer very short. 0.91. What is the ratio of the Imports(as % of merchandise exports) of Israel in 2007 to that in 2009?
Ensure brevity in your answer.  0.93. What is the ratio of the Imports(as % of merchandise exports) of Yemen, Rep. in 2007 to that in 2009?
Make the answer very short. 1.03. What is the ratio of the Imports(as % of merchandise exports) of Barbados in 2008 to that in 2009?
Provide a short and direct response. 1.33. What is the ratio of the Imports(as % of merchandise exports) of Bhutan in 2008 to that in 2009?
Your answer should be compact. 1. What is the ratio of the Imports(as % of merchandise exports) of Israel in 2008 to that in 2009?
Provide a short and direct response. 1.16. What is the ratio of the Imports(as % of merchandise exports) of Yemen, Rep. in 2008 to that in 2009?
Provide a short and direct response. 1.38. What is the difference between the highest and the second highest Imports(as % of merchandise exports) in Barbados?
Keep it short and to the point. 0.6. What is the difference between the highest and the second highest Imports(as % of merchandise exports) in Bhutan?
Keep it short and to the point. 0.07. What is the difference between the highest and the second highest Imports(as % of merchandise exports) of Israel?
Your answer should be very brief. 2.68. What is the difference between the highest and the second highest Imports(as % of merchandise exports) of Yemen, Rep.?
Ensure brevity in your answer.  7.34. What is the difference between the highest and the lowest Imports(as % of merchandise exports) of Barbados?
Make the answer very short. 16.97. What is the difference between the highest and the lowest Imports(as % of merchandise exports) of Bhutan?
Offer a very short reply. 7.16. What is the difference between the highest and the lowest Imports(as % of merchandise exports) in Israel?
Offer a very short reply. 13.15. What is the difference between the highest and the lowest Imports(as % of merchandise exports) of Yemen, Rep.?
Keep it short and to the point. 22.45. 